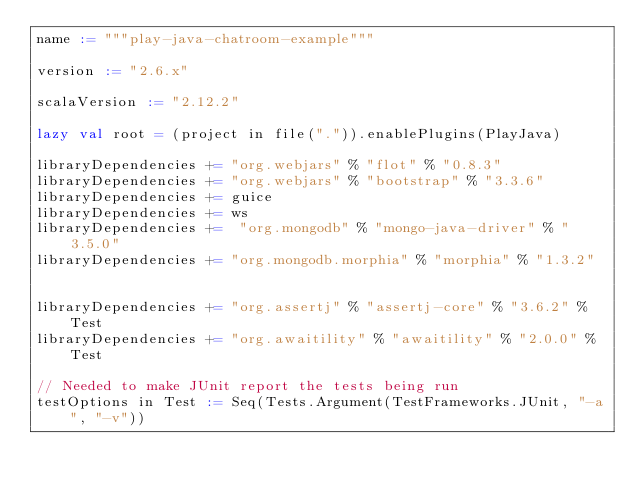<code> <loc_0><loc_0><loc_500><loc_500><_Scala_>name := """play-java-chatroom-example"""

version := "2.6.x"

scalaVersion := "2.12.2"

lazy val root = (project in file(".")).enablePlugins(PlayJava)

libraryDependencies += "org.webjars" % "flot" % "0.8.3"
libraryDependencies += "org.webjars" % "bootstrap" % "3.3.6"
libraryDependencies += guice
libraryDependencies += ws
libraryDependencies +=  "org.mongodb" % "mongo-java-driver" % "3.5.0"
libraryDependencies += "org.mongodb.morphia" % "morphia" % "1.3.2"


libraryDependencies += "org.assertj" % "assertj-core" % "3.6.2" % Test
libraryDependencies += "org.awaitility" % "awaitility" % "2.0.0" % Test

// Needed to make JUnit report the tests being run
testOptions in Test := Seq(Tests.Argument(TestFrameworks.JUnit, "-a", "-v"))
</code> 